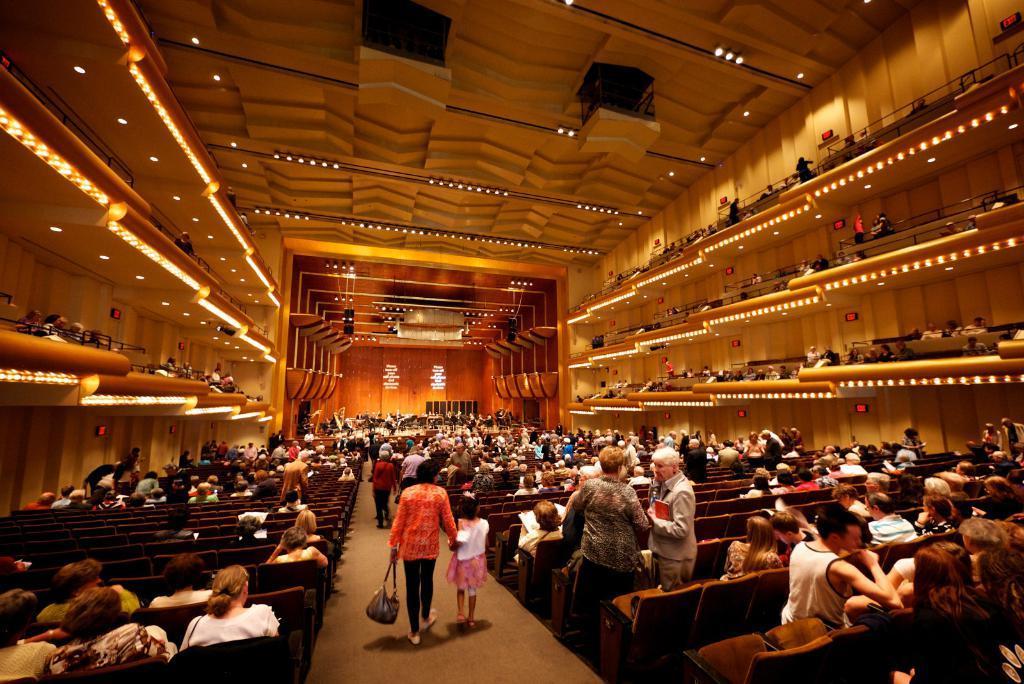Describe this image in one or two sentences. In this image I can see a crow is sitting on the chairs and are standing on the floor. In the background I can see a stage, fence and a rooftop on which lights are mounted. This image is taken may be in a hall. 